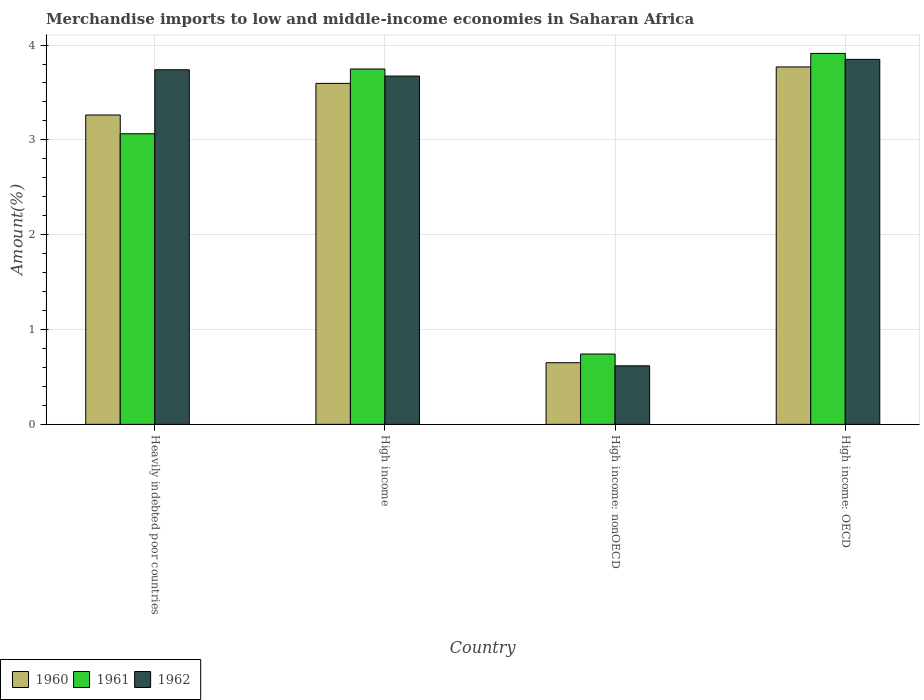How many groups of bars are there?
Offer a very short reply. 4. Are the number of bars per tick equal to the number of legend labels?
Your response must be concise. Yes. Are the number of bars on each tick of the X-axis equal?
Provide a short and direct response. Yes. How many bars are there on the 1st tick from the right?
Your answer should be very brief. 3. What is the label of the 4th group of bars from the left?
Provide a short and direct response. High income: OECD. In how many cases, is the number of bars for a given country not equal to the number of legend labels?
Offer a terse response. 0. What is the percentage of amount earned from merchandise imports in 1961 in Heavily indebted poor countries?
Keep it short and to the point. 3.06. Across all countries, what is the maximum percentage of amount earned from merchandise imports in 1960?
Provide a short and direct response. 3.77. Across all countries, what is the minimum percentage of amount earned from merchandise imports in 1962?
Keep it short and to the point. 0.62. In which country was the percentage of amount earned from merchandise imports in 1962 maximum?
Offer a very short reply. High income: OECD. In which country was the percentage of amount earned from merchandise imports in 1961 minimum?
Ensure brevity in your answer.  High income: nonOECD. What is the total percentage of amount earned from merchandise imports in 1962 in the graph?
Provide a succinct answer. 11.88. What is the difference between the percentage of amount earned from merchandise imports in 1960 in Heavily indebted poor countries and that in High income?
Keep it short and to the point. -0.33. What is the difference between the percentage of amount earned from merchandise imports in 1960 in High income: nonOECD and the percentage of amount earned from merchandise imports in 1962 in High income: OECD?
Give a very brief answer. -3.2. What is the average percentage of amount earned from merchandise imports in 1960 per country?
Your answer should be very brief. 2.82. What is the difference between the percentage of amount earned from merchandise imports of/in 1961 and percentage of amount earned from merchandise imports of/in 1960 in Heavily indebted poor countries?
Give a very brief answer. -0.2. In how many countries, is the percentage of amount earned from merchandise imports in 1962 greater than 3 %?
Offer a terse response. 3. What is the ratio of the percentage of amount earned from merchandise imports in 1962 in Heavily indebted poor countries to that in High income: OECD?
Ensure brevity in your answer.  0.97. What is the difference between the highest and the second highest percentage of amount earned from merchandise imports in 1962?
Offer a terse response. -0.11. What is the difference between the highest and the lowest percentage of amount earned from merchandise imports in 1960?
Ensure brevity in your answer.  3.12. In how many countries, is the percentage of amount earned from merchandise imports in 1960 greater than the average percentage of amount earned from merchandise imports in 1960 taken over all countries?
Make the answer very short. 3. How many bars are there?
Offer a terse response. 12. Are all the bars in the graph horizontal?
Keep it short and to the point. No. How many countries are there in the graph?
Offer a terse response. 4. What is the difference between two consecutive major ticks on the Y-axis?
Offer a very short reply. 1. How are the legend labels stacked?
Offer a very short reply. Horizontal. What is the title of the graph?
Ensure brevity in your answer.  Merchandise imports to low and middle-income economies in Saharan Africa. What is the label or title of the X-axis?
Provide a short and direct response. Country. What is the label or title of the Y-axis?
Provide a short and direct response. Amount(%). What is the Amount(%) in 1960 in Heavily indebted poor countries?
Offer a terse response. 3.26. What is the Amount(%) of 1961 in Heavily indebted poor countries?
Provide a succinct answer. 3.06. What is the Amount(%) of 1962 in Heavily indebted poor countries?
Give a very brief answer. 3.74. What is the Amount(%) of 1960 in High income?
Give a very brief answer. 3.6. What is the Amount(%) in 1961 in High income?
Provide a succinct answer. 3.75. What is the Amount(%) in 1962 in High income?
Offer a terse response. 3.67. What is the Amount(%) of 1960 in High income: nonOECD?
Your answer should be compact. 0.65. What is the Amount(%) in 1961 in High income: nonOECD?
Make the answer very short. 0.74. What is the Amount(%) in 1962 in High income: nonOECD?
Offer a terse response. 0.62. What is the Amount(%) in 1960 in High income: OECD?
Offer a terse response. 3.77. What is the Amount(%) in 1961 in High income: OECD?
Provide a short and direct response. 3.91. What is the Amount(%) in 1962 in High income: OECD?
Keep it short and to the point. 3.85. Across all countries, what is the maximum Amount(%) in 1960?
Make the answer very short. 3.77. Across all countries, what is the maximum Amount(%) in 1961?
Your answer should be compact. 3.91. Across all countries, what is the maximum Amount(%) in 1962?
Your response must be concise. 3.85. Across all countries, what is the minimum Amount(%) in 1960?
Offer a very short reply. 0.65. Across all countries, what is the minimum Amount(%) of 1961?
Provide a short and direct response. 0.74. Across all countries, what is the minimum Amount(%) of 1962?
Offer a very short reply. 0.62. What is the total Amount(%) of 1960 in the graph?
Offer a terse response. 11.28. What is the total Amount(%) in 1961 in the graph?
Your answer should be compact. 11.47. What is the total Amount(%) of 1962 in the graph?
Offer a terse response. 11.88. What is the difference between the Amount(%) in 1961 in Heavily indebted poor countries and that in High income?
Provide a succinct answer. -0.68. What is the difference between the Amount(%) in 1962 in Heavily indebted poor countries and that in High income?
Your answer should be very brief. 0.07. What is the difference between the Amount(%) in 1960 in Heavily indebted poor countries and that in High income: nonOECD?
Provide a short and direct response. 2.61. What is the difference between the Amount(%) of 1961 in Heavily indebted poor countries and that in High income: nonOECD?
Your response must be concise. 2.32. What is the difference between the Amount(%) in 1962 in Heavily indebted poor countries and that in High income: nonOECD?
Keep it short and to the point. 3.12. What is the difference between the Amount(%) in 1960 in Heavily indebted poor countries and that in High income: OECD?
Your answer should be compact. -0.51. What is the difference between the Amount(%) in 1961 in Heavily indebted poor countries and that in High income: OECD?
Make the answer very short. -0.85. What is the difference between the Amount(%) in 1962 in Heavily indebted poor countries and that in High income: OECD?
Make the answer very short. -0.11. What is the difference between the Amount(%) of 1960 in High income and that in High income: nonOECD?
Provide a short and direct response. 2.95. What is the difference between the Amount(%) in 1961 in High income and that in High income: nonOECD?
Your answer should be very brief. 3.01. What is the difference between the Amount(%) in 1962 in High income and that in High income: nonOECD?
Offer a very short reply. 3.06. What is the difference between the Amount(%) in 1960 in High income and that in High income: OECD?
Your answer should be very brief. -0.17. What is the difference between the Amount(%) of 1961 in High income and that in High income: OECD?
Your response must be concise. -0.16. What is the difference between the Amount(%) in 1962 in High income and that in High income: OECD?
Keep it short and to the point. -0.18. What is the difference between the Amount(%) in 1960 in High income: nonOECD and that in High income: OECD?
Give a very brief answer. -3.12. What is the difference between the Amount(%) of 1961 in High income: nonOECD and that in High income: OECD?
Your answer should be very brief. -3.17. What is the difference between the Amount(%) in 1962 in High income: nonOECD and that in High income: OECD?
Your response must be concise. -3.23. What is the difference between the Amount(%) in 1960 in Heavily indebted poor countries and the Amount(%) in 1961 in High income?
Provide a succinct answer. -0.49. What is the difference between the Amount(%) in 1960 in Heavily indebted poor countries and the Amount(%) in 1962 in High income?
Provide a short and direct response. -0.41. What is the difference between the Amount(%) in 1961 in Heavily indebted poor countries and the Amount(%) in 1962 in High income?
Give a very brief answer. -0.61. What is the difference between the Amount(%) of 1960 in Heavily indebted poor countries and the Amount(%) of 1961 in High income: nonOECD?
Your response must be concise. 2.52. What is the difference between the Amount(%) in 1960 in Heavily indebted poor countries and the Amount(%) in 1962 in High income: nonOECD?
Your answer should be compact. 2.65. What is the difference between the Amount(%) in 1961 in Heavily indebted poor countries and the Amount(%) in 1962 in High income: nonOECD?
Ensure brevity in your answer.  2.45. What is the difference between the Amount(%) of 1960 in Heavily indebted poor countries and the Amount(%) of 1961 in High income: OECD?
Provide a succinct answer. -0.65. What is the difference between the Amount(%) in 1960 in Heavily indebted poor countries and the Amount(%) in 1962 in High income: OECD?
Ensure brevity in your answer.  -0.59. What is the difference between the Amount(%) in 1961 in Heavily indebted poor countries and the Amount(%) in 1962 in High income: OECD?
Your answer should be compact. -0.78. What is the difference between the Amount(%) of 1960 in High income and the Amount(%) of 1961 in High income: nonOECD?
Your answer should be very brief. 2.85. What is the difference between the Amount(%) in 1960 in High income and the Amount(%) in 1962 in High income: nonOECD?
Provide a succinct answer. 2.98. What is the difference between the Amount(%) in 1961 in High income and the Amount(%) in 1962 in High income: nonOECD?
Provide a succinct answer. 3.13. What is the difference between the Amount(%) in 1960 in High income and the Amount(%) in 1961 in High income: OECD?
Offer a terse response. -0.32. What is the difference between the Amount(%) in 1960 in High income and the Amount(%) in 1962 in High income: OECD?
Offer a terse response. -0.25. What is the difference between the Amount(%) of 1961 in High income and the Amount(%) of 1962 in High income: OECD?
Offer a terse response. -0.1. What is the difference between the Amount(%) in 1960 in High income: nonOECD and the Amount(%) in 1961 in High income: OECD?
Keep it short and to the point. -3.26. What is the difference between the Amount(%) of 1960 in High income: nonOECD and the Amount(%) of 1962 in High income: OECD?
Offer a very short reply. -3.2. What is the difference between the Amount(%) of 1961 in High income: nonOECD and the Amount(%) of 1962 in High income: OECD?
Offer a terse response. -3.11. What is the average Amount(%) in 1960 per country?
Your answer should be compact. 2.82. What is the average Amount(%) in 1961 per country?
Your response must be concise. 2.87. What is the average Amount(%) of 1962 per country?
Your answer should be very brief. 2.97. What is the difference between the Amount(%) in 1960 and Amount(%) in 1961 in Heavily indebted poor countries?
Provide a succinct answer. 0.2. What is the difference between the Amount(%) of 1960 and Amount(%) of 1962 in Heavily indebted poor countries?
Provide a short and direct response. -0.48. What is the difference between the Amount(%) in 1961 and Amount(%) in 1962 in Heavily indebted poor countries?
Your answer should be very brief. -0.67. What is the difference between the Amount(%) of 1960 and Amount(%) of 1961 in High income?
Your answer should be very brief. -0.15. What is the difference between the Amount(%) in 1960 and Amount(%) in 1962 in High income?
Keep it short and to the point. -0.08. What is the difference between the Amount(%) of 1961 and Amount(%) of 1962 in High income?
Offer a very short reply. 0.07. What is the difference between the Amount(%) of 1960 and Amount(%) of 1961 in High income: nonOECD?
Ensure brevity in your answer.  -0.09. What is the difference between the Amount(%) in 1960 and Amount(%) in 1962 in High income: nonOECD?
Give a very brief answer. 0.03. What is the difference between the Amount(%) of 1961 and Amount(%) of 1962 in High income: nonOECD?
Ensure brevity in your answer.  0.12. What is the difference between the Amount(%) of 1960 and Amount(%) of 1961 in High income: OECD?
Make the answer very short. -0.14. What is the difference between the Amount(%) in 1960 and Amount(%) in 1962 in High income: OECD?
Make the answer very short. -0.08. What is the difference between the Amount(%) of 1961 and Amount(%) of 1962 in High income: OECD?
Give a very brief answer. 0.06. What is the ratio of the Amount(%) in 1960 in Heavily indebted poor countries to that in High income?
Keep it short and to the point. 0.91. What is the ratio of the Amount(%) in 1961 in Heavily indebted poor countries to that in High income?
Offer a terse response. 0.82. What is the ratio of the Amount(%) in 1960 in Heavily indebted poor countries to that in High income: nonOECD?
Offer a terse response. 5.02. What is the ratio of the Amount(%) in 1961 in Heavily indebted poor countries to that in High income: nonOECD?
Ensure brevity in your answer.  4.13. What is the ratio of the Amount(%) in 1962 in Heavily indebted poor countries to that in High income: nonOECD?
Keep it short and to the point. 6.06. What is the ratio of the Amount(%) in 1960 in Heavily indebted poor countries to that in High income: OECD?
Keep it short and to the point. 0.87. What is the ratio of the Amount(%) in 1961 in Heavily indebted poor countries to that in High income: OECD?
Provide a succinct answer. 0.78. What is the ratio of the Amount(%) in 1962 in Heavily indebted poor countries to that in High income: OECD?
Provide a succinct answer. 0.97. What is the ratio of the Amount(%) of 1960 in High income to that in High income: nonOECD?
Offer a very short reply. 5.53. What is the ratio of the Amount(%) in 1961 in High income to that in High income: nonOECD?
Provide a short and direct response. 5.05. What is the ratio of the Amount(%) of 1962 in High income to that in High income: nonOECD?
Give a very brief answer. 5.95. What is the ratio of the Amount(%) in 1960 in High income to that in High income: OECD?
Ensure brevity in your answer.  0.95. What is the ratio of the Amount(%) in 1961 in High income to that in High income: OECD?
Offer a terse response. 0.96. What is the ratio of the Amount(%) of 1962 in High income to that in High income: OECD?
Provide a succinct answer. 0.95. What is the ratio of the Amount(%) of 1960 in High income: nonOECD to that in High income: OECD?
Give a very brief answer. 0.17. What is the ratio of the Amount(%) of 1961 in High income: nonOECD to that in High income: OECD?
Your answer should be compact. 0.19. What is the ratio of the Amount(%) of 1962 in High income: nonOECD to that in High income: OECD?
Offer a terse response. 0.16. What is the difference between the highest and the second highest Amount(%) in 1960?
Offer a terse response. 0.17. What is the difference between the highest and the second highest Amount(%) in 1961?
Your answer should be very brief. 0.16. What is the difference between the highest and the second highest Amount(%) of 1962?
Keep it short and to the point. 0.11. What is the difference between the highest and the lowest Amount(%) in 1960?
Make the answer very short. 3.12. What is the difference between the highest and the lowest Amount(%) in 1961?
Your answer should be compact. 3.17. What is the difference between the highest and the lowest Amount(%) of 1962?
Make the answer very short. 3.23. 